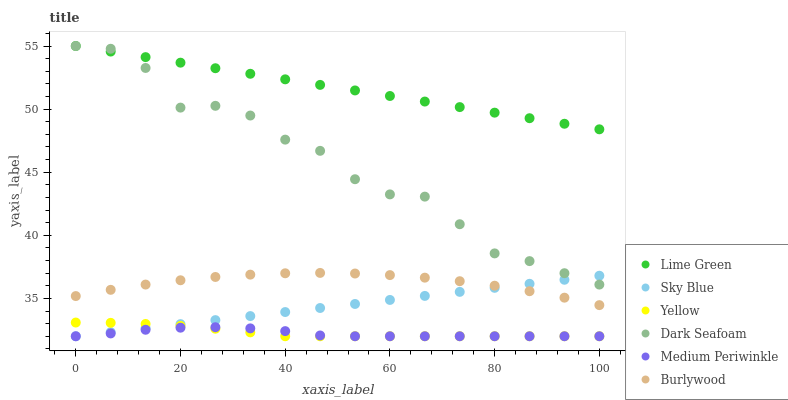Does Medium Periwinkle have the minimum area under the curve?
Answer yes or no. Yes. Does Lime Green have the maximum area under the curve?
Answer yes or no. Yes. Does Yellow have the minimum area under the curve?
Answer yes or no. No. Does Yellow have the maximum area under the curve?
Answer yes or no. No. Is Sky Blue the smoothest?
Answer yes or no. Yes. Is Dark Seafoam the roughest?
Answer yes or no. Yes. Is Medium Periwinkle the smoothest?
Answer yes or no. No. Is Medium Periwinkle the roughest?
Answer yes or no. No. Does Medium Periwinkle have the lowest value?
Answer yes or no. Yes. Does Dark Seafoam have the lowest value?
Answer yes or no. No. Does Lime Green have the highest value?
Answer yes or no. Yes. Does Yellow have the highest value?
Answer yes or no. No. Is Yellow less than Lime Green?
Answer yes or no. Yes. Is Dark Seafoam greater than Medium Periwinkle?
Answer yes or no. Yes. Does Lime Green intersect Dark Seafoam?
Answer yes or no. Yes. Is Lime Green less than Dark Seafoam?
Answer yes or no. No. Is Lime Green greater than Dark Seafoam?
Answer yes or no. No. Does Yellow intersect Lime Green?
Answer yes or no. No. 